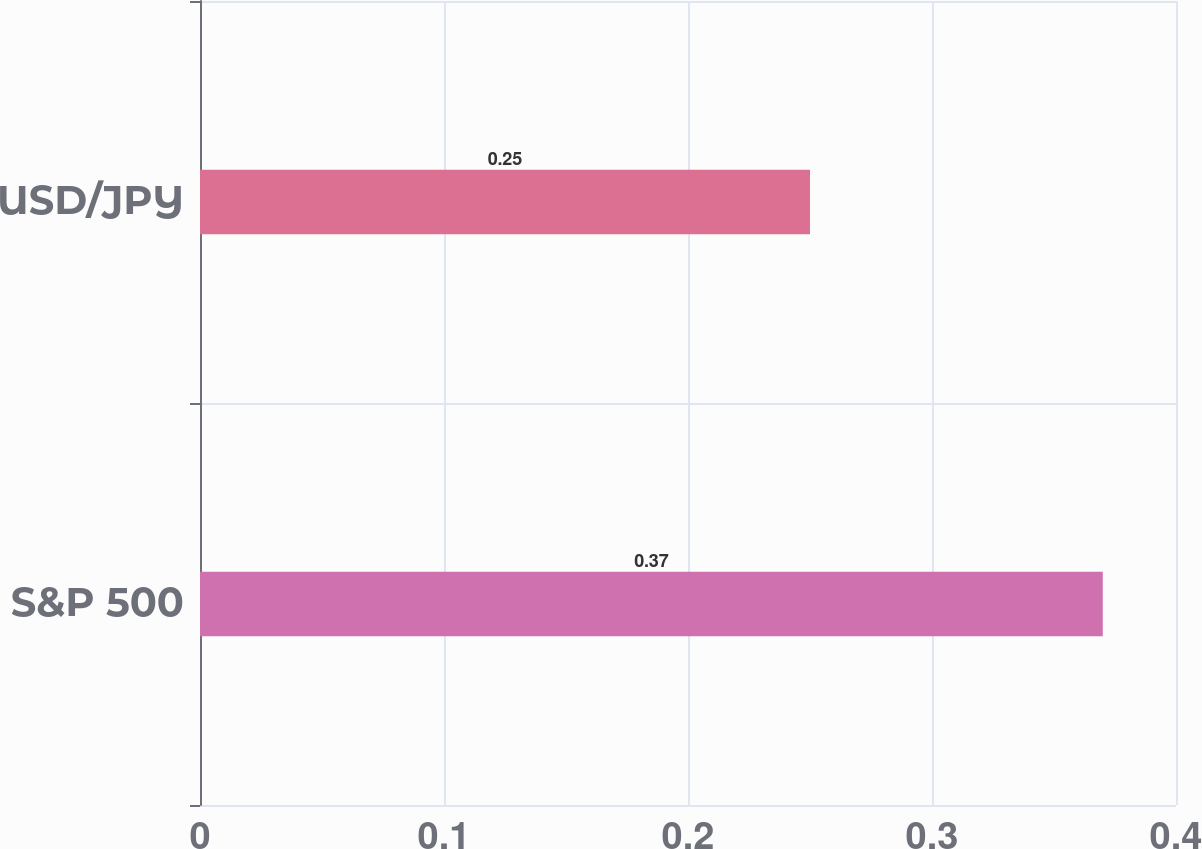<chart> <loc_0><loc_0><loc_500><loc_500><bar_chart><fcel>S&P 500<fcel>USD/JPY<nl><fcel>0.37<fcel>0.25<nl></chart> 